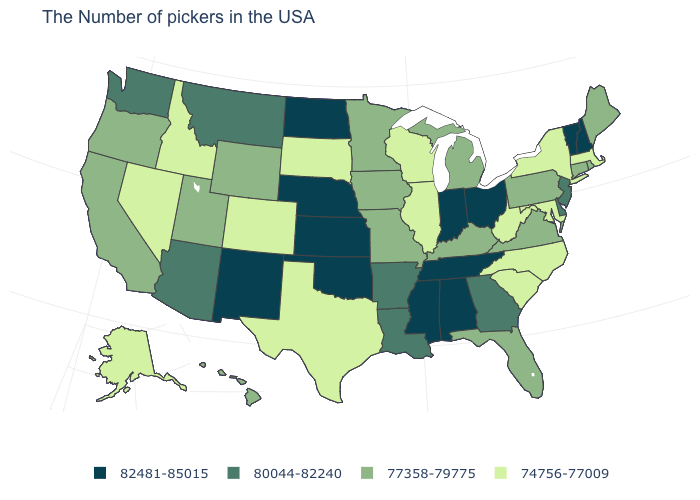Does Indiana have the highest value in the MidWest?
Keep it brief. Yes. How many symbols are there in the legend?
Write a very short answer. 4. Which states hav the highest value in the West?
Be succinct. New Mexico. Among the states that border Idaho , does Washington have the highest value?
Concise answer only. Yes. Which states have the lowest value in the Northeast?
Write a very short answer. Massachusetts, New York. How many symbols are there in the legend?
Short answer required. 4. Among the states that border New Hampshire , does Vermont have the highest value?
Concise answer only. Yes. Does Massachusetts have a lower value than New Jersey?
Keep it brief. Yes. What is the value of Wyoming?
Quick response, please. 77358-79775. Which states have the lowest value in the West?
Write a very short answer. Colorado, Idaho, Nevada, Alaska. Does New York have the lowest value in the USA?
Give a very brief answer. Yes. How many symbols are there in the legend?
Concise answer only. 4. Is the legend a continuous bar?
Give a very brief answer. No. Name the states that have a value in the range 82481-85015?
Keep it brief. New Hampshire, Vermont, Ohio, Indiana, Alabama, Tennessee, Mississippi, Kansas, Nebraska, Oklahoma, North Dakota, New Mexico. Which states have the lowest value in the Northeast?
Keep it brief. Massachusetts, New York. 